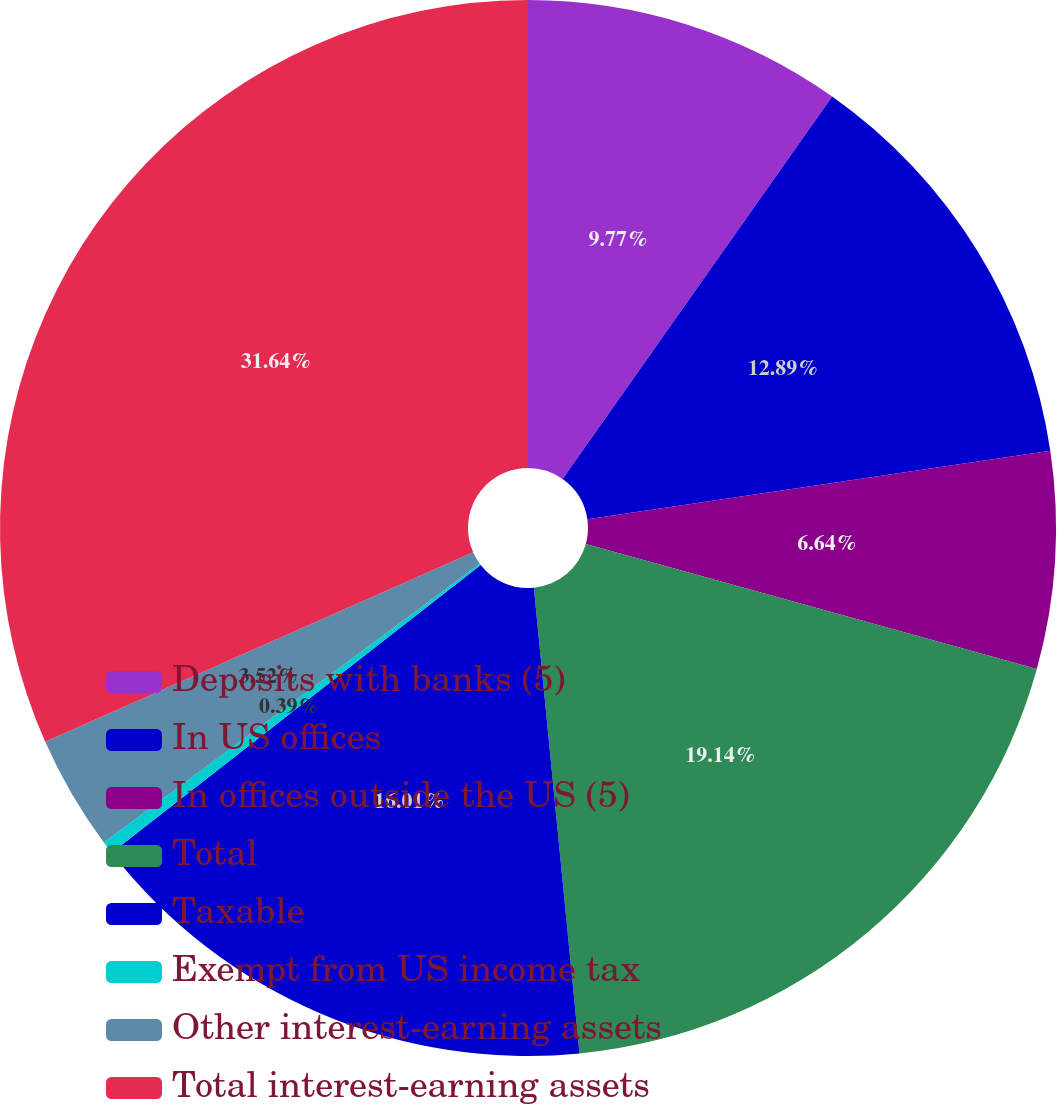<chart> <loc_0><loc_0><loc_500><loc_500><pie_chart><fcel>Deposits with banks (5)<fcel>In US offices<fcel>In offices outside the US (5)<fcel>Total<fcel>Taxable<fcel>Exempt from US income tax<fcel>Other interest-earning assets<fcel>Total interest-earning assets<nl><fcel>9.77%<fcel>12.89%<fcel>6.64%<fcel>19.14%<fcel>16.01%<fcel>0.39%<fcel>3.52%<fcel>31.63%<nl></chart> 